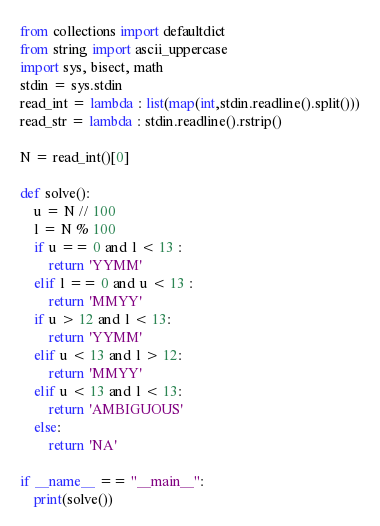<code> <loc_0><loc_0><loc_500><loc_500><_Python_>from collections import defaultdict
from string import ascii_uppercase
import sys, bisect, math
stdin = sys.stdin
read_int = lambda : list(map(int,stdin.readline().split()))
read_str = lambda : stdin.readline().rstrip()

N = read_int()[0]

def solve():
    u = N // 100
    l = N % 100
    if u == 0 and l < 13 :
        return 'YYMM'
    elif l == 0 and u < 13 :
        return 'MMYY'
    if u > 12 and l < 13:
        return 'YYMM'
    elif u < 13 and l > 12:
        return 'MMYY'
    elif u < 13 and l < 13:
        return 'AMBIGUOUS'
    else:
        return 'NA'

if __name__ == "__main__":
    print(solve())
</code> 